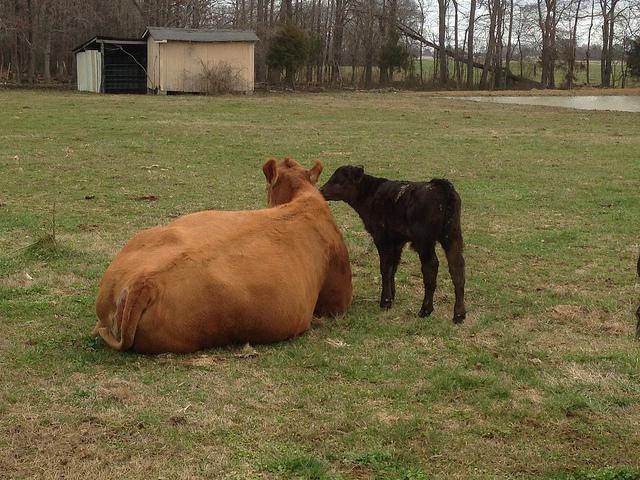How many cows are standing?
Give a very brief answer. 1. How many animals are lying down?
Give a very brief answer. 1. How many animals can you see?
Give a very brief answer. 2. How many horns does the animal have?
Give a very brief answer. 0. How many hooves are visible?
Give a very brief answer. 3. How many cows are there?
Give a very brief answer. 2. 